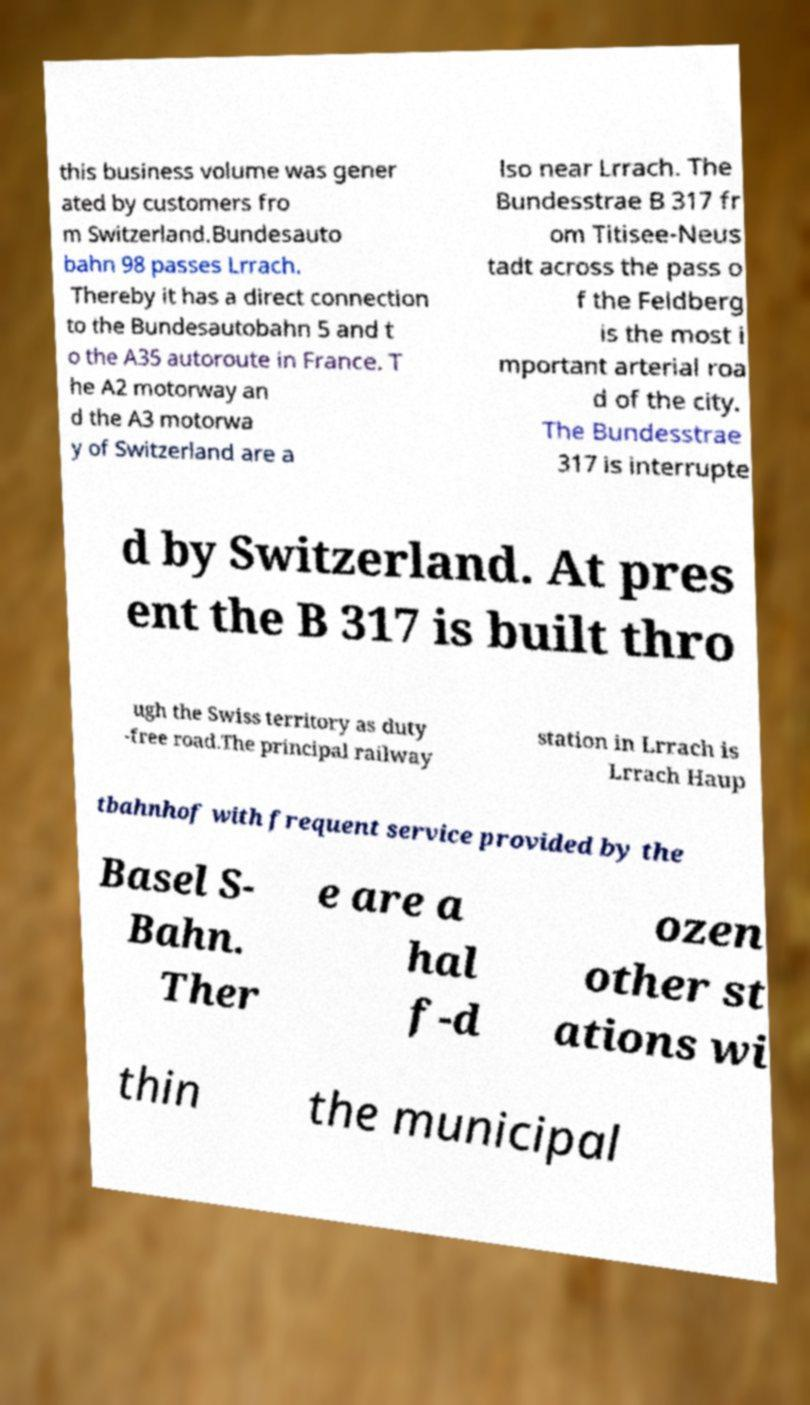Could you assist in decoding the text presented in this image and type it out clearly? this business volume was gener ated by customers fro m Switzerland.Bundesauto bahn 98 passes Lrrach. Thereby it has a direct connection to the Bundesautobahn 5 and t o the A35 autoroute in France. T he A2 motorway an d the A3 motorwa y of Switzerland are a lso near Lrrach. The Bundesstrae B 317 fr om Titisee-Neus tadt across the pass o f the Feldberg is the most i mportant arterial roa d of the city. The Bundesstrae 317 is interrupte d by Switzerland. At pres ent the B 317 is built thro ugh the Swiss territory as duty -free road.The principal railway station in Lrrach is Lrrach Haup tbahnhof with frequent service provided by the Basel S- Bahn. Ther e are a hal f-d ozen other st ations wi thin the municipal 